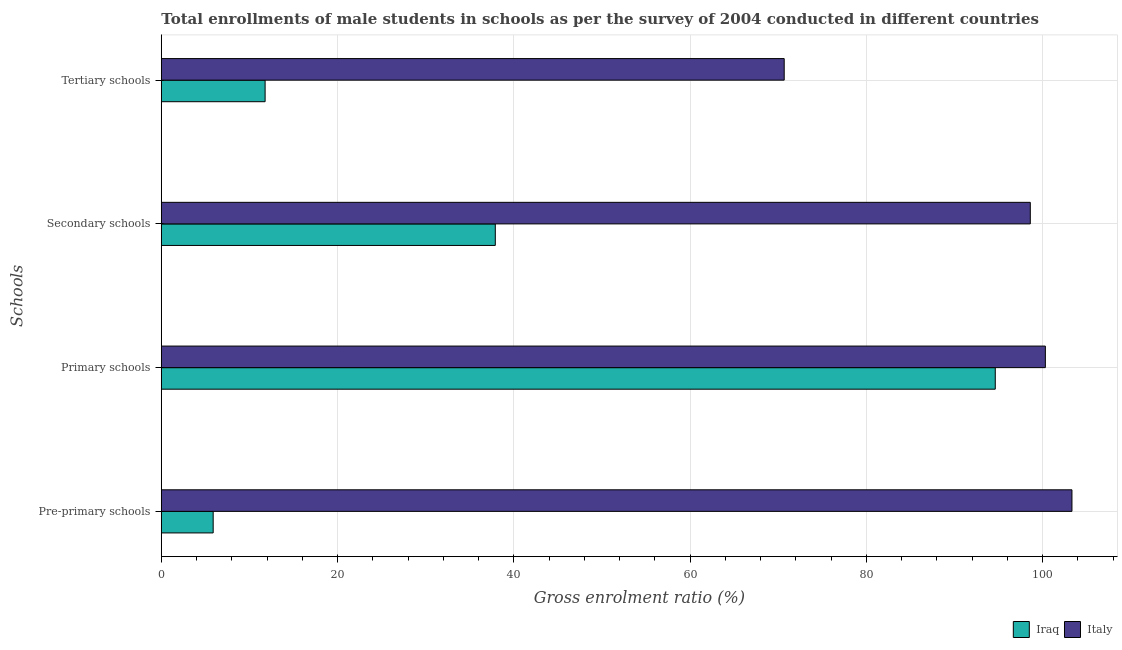How many groups of bars are there?
Your response must be concise. 4. Are the number of bars per tick equal to the number of legend labels?
Make the answer very short. Yes. What is the label of the 1st group of bars from the top?
Keep it short and to the point. Tertiary schools. What is the gross enrolment ratio(male) in tertiary schools in Italy?
Ensure brevity in your answer.  70.68. Across all countries, what is the maximum gross enrolment ratio(male) in tertiary schools?
Offer a very short reply. 70.68. Across all countries, what is the minimum gross enrolment ratio(male) in pre-primary schools?
Provide a succinct answer. 5.88. In which country was the gross enrolment ratio(male) in tertiary schools minimum?
Make the answer very short. Iraq. What is the total gross enrolment ratio(male) in secondary schools in the graph?
Make the answer very short. 136.51. What is the difference between the gross enrolment ratio(male) in primary schools in Italy and that in Iraq?
Your answer should be very brief. 5.68. What is the difference between the gross enrolment ratio(male) in primary schools in Iraq and the gross enrolment ratio(male) in tertiary schools in Italy?
Keep it short and to the point. 23.95. What is the average gross enrolment ratio(male) in tertiary schools per country?
Ensure brevity in your answer.  41.23. What is the difference between the gross enrolment ratio(male) in secondary schools and gross enrolment ratio(male) in pre-primary schools in Iraq?
Provide a short and direct response. 32.02. What is the ratio of the gross enrolment ratio(male) in tertiary schools in Iraq to that in Italy?
Provide a short and direct response. 0.17. Is the difference between the gross enrolment ratio(male) in secondary schools in Iraq and Italy greater than the difference between the gross enrolment ratio(male) in primary schools in Iraq and Italy?
Offer a very short reply. No. What is the difference between the highest and the second highest gross enrolment ratio(male) in primary schools?
Your response must be concise. 5.68. What is the difference between the highest and the lowest gross enrolment ratio(male) in secondary schools?
Ensure brevity in your answer.  60.71. In how many countries, is the gross enrolment ratio(male) in primary schools greater than the average gross enrolment ratio(male) in primary schools taken over all countries?
Your answer should be very brief. 1. Is the sum of the gross enrolment ratio(male) in tertiary schools in Italy and Iraq greater than the maximum gross enrolment ratio(male) in primary schools across all countries?
Provide a succinct answer. No. Is it the case that in every country, the sum of the gross enrolment ratio(male) in pre-primary schools and gross enrolment ratio(male) in primary schools is greater than the sum of gross enrolment ratio(male) in tertiary schools and gross enrolment ratio(male) in secondary schools?
Make the answer very short. No. What does the 2nd bar from the top in Tertiary schools represents?
Offer a terse response. Iraq. What does the 2nd bar from the bottom in Pre-primary schools represents?
Ensure brevity in your answer.  Italy. Are all the bars in the graph horizontal?
Your answer should be very brief. Yes. How many countries are there in the graph?
Provide a succinct answer. 2. What is the difference between two consecutive major ticks on the X-axis?
Your answer should be compact. 20. Are the values on the major ticks of X-axis written in scientific E-notation?
Your answer should be very brief. No. How many legend labels are there?
Offer a terse response. 2. How are the legend labels stacked?
Your response must be concise. Horizontal. What is the title of the graph?
Your response must be concise. Total enrollments of male students in schools as per the survey of 2004 conducted in different countries. Does "East Asia (all income levels)" appear as one of the legend labels in the graph?
Your answer should be compact. No. What is the label or title of the Y-axis?
Give a very brief answer. Schools. What is the Gross enrolment ratio (%) of Iraq in Pre-primary schools?
Ensure brevity in your answer.  5.88. What is the Gross enrolment ratio (%) of Italy in Pre-primary schools?
Offer a very short reply. 103.34. What is the Gross enrolment ratio (%) in Iraq in Primary schools?
Make the answer very short. 94.64. What is the Gross enrolment ratio (%) in Italy in Primary schools?
Provide a succinct answer. 100.32. What is the Gross enrolment ratio (%) of Iraq in Secondary schools?
Your response must be concise. 37.9. What is the Gross enrolment ratio (%) of Italy in Secondary schools?
Give a very brief answer. 98.61. What is the Gross enrolment ratio (%) in Iraq in Tertiary schools?
Offer a terse response. 11.78. What is the Gross enrolment ratio (%) of Italy in Tertiary schools?
Your answer should be very brief. 70.68. Across all Schools, what is the maximum Gross enrolment ratio (%) of Iraq?
Give a very brief answer. 94.64. Across all Schools, what is the maximum Gross enrolment ratio (%) in Italy?
Provide a short and direct response. 103.34. Across all Schools, what is the minimum Gross enrolment ratio (%) in Iraq?
Offer a terse response. 5.88. Across all Schools, what is the minimum Gross enrolment ratio (%) of Italy?
Give a very brief answer. 70.68. What is the total Gross enrolment ratio (%) in Iraq in the graph?
Your answer should be compact. 150.2. What is the total Gross enrolment ratio (%) of Italy in the graph?
Give a very brief answer. 372.95. What is the difference between the Gross enrolment ratio (%) in Iraq in Pre-primary schools and that in Primary schools?
Offer a terse response. -88.75. What is the difference between the Gross enrolment ratio (%) of Italy in Pre-primary schools and that in Primary schools?
Offer a very short reply. 3.02. What is the difference between the Gross enrolment ratio (%) of Iraq in Pre-primary schools and that in Secondary schools?
Keep it short and to the point. -32.02. What is the difference between the Gross enrolment ratio (%) of Italy in Pre-primary schools and that in Secondary schools?
Your response must be concise. 4.73. What is the difference between the Gross enrolment ratio (%) of Iraq in Pre-primary schools and that in Tertiary schools?
Your answer should be compact. -5.89. What is the difference between the Gross enrolment ratio (%) in Italy in Pre-primary schools and that in Tertiary schools?
Keep it short and to the point. 32.65. What is the difference between the Gross enrolment ratio (%) in Iraq in Primary schools and that in Secondary schools?
Provide a short and direct response. 56.74. What is the difference between the Gross enrolment ratio (%) in Italy in Primary schools and that in Secondary schools?
Give a very brief answer. 1.71. What is the difference between the Gross enrolment ratio (%) of Iraq in Primary schools and that in Tertiary schools?
Provide a succinct answer. 82.86. What is the difference between the Gross enrolment ratio (%) of Italy in Primary schools and that in Tertiary schools?
Make the answer very short. 29.64. What is the difference between the Gross enrolment ratio (%) in Iraq in Secondary schools and that in Tertiary schools?
Provide a short and direct response. 26.12. What is the difference between the Gross enrolment ratio (%) of Italy in Secondary schools and that in Tertiary schools?
Give a very brief answer. 27.93. What is the difference between the Gross enrolment ratio (%) in Iraq in Pre-primary schools and the Gross enrolment ratio (%) in Italy in Primary schools?
Your response must be concise. -94.44. What is the difference between the Gross enrolment ratio (%) in Iraq in Pre-primary schools and the Gross enrolment ratio (%) in Italy in Secondary schools?
Give a very brief answer. -92.73. What is the difference between the Gross enrolment ratio (%) in Iraq in Pre-primary schools and the Gross enrolment ratio (%) in Italy in Tertiary schools?
Give a very brief answer. -64.8. What is the difference between the Gross enrolment ratio (%) in Iraq in Primary schools and the Gross enrolment ratio (%) in Italy in Secondary schools?
Provide a short and direct response. -3.98. What is the difference between the Gross enrolment ratio (%) in Iraq in Primary schools and the Gross enrolment ratio (%) in Italy in Tertiary schools?
Provide a succinct answer. 23.95. What is the difference between the Gross enrolment ratio (%) in Iraq in Secondary schools and the Gross enrolment ratio (%) in Italy in Tertiary schools?
Provide a short and direct response. -32.78. What is the average Gross enrolment ratio (%) in Iraq per Schools?
Make the answer very short. 37.55. What is the average Gross enrolment ratio (%) in Italy per Schools?
Offer a terse response. 93.24. What is the difference between the Gross enrolment ratio (%) in Iraq and Gross enrolment ratio (%) in Italy in Pre-primary schools?
Give a very brief answer. -97.45. What is the difference between the Gross enrolment ratio (%) of Iraq and Gross enrolment ratio (%) of Italy in Primary schools?
Make the answer very short. -5.68. What is the difference between the Gross enrolment ratio (%) of Iraq and Gross enrolment ratio (%) of Italy in Secondary schools?
Provide a succinct answer. -60.71. What is the difference between the Gross enrolment ratio (%) of Iraq and Gross enrolment ratio (%) of Italy in Tertiary schools?
Provide a short and direct response. -58.9. What is the ratio of the Gross enrolment ratio (%) of Iraq in Pre-primary schools to that in Primary schools?
Offer a very short reply. 0.06. What is the ratio of the Gross enrolment ratio (%) in Italy in Pre-primary schools to that in Primary schools?
Provide a short and direct response. 1.03. What is the ratio of the Gross enrolment ratio (%) of Iraq in Pre-primary schools to that in Secondary schools?
Give a very brief answer. 0.16. What is the ratio of the Gross enrolment ratio (%) of Italy in Pre-primary schools to that in Secondary schools?
Ensure brevity in your answer.  1.05. What is the ratio of the Gross enrolment ratio (%) in Iraq in Pre-primary schools to that in Tertiary schools?
Offer a very short reply. 0.5. What is the ratio of the Gross enrolment ratio (%) of Italy in Pre-primary schools to that in Tertiary schools?
Keep it short and to the point. 1.46. What is the ratio of the Gross enrolment ratio (%) of Iraq in Primary schools to that in Secondary schools?
Ensure brevity in your answer.  2.5. What is the ratio of the Gross enrolment ratio (%) of Italy in Primary schools to that in Secondary schools?
Your answer should be very brief. 1.02. What is the ratio of the Gross enrolment ratio (%) of Iraq in Primary schools to that in Tertiary schools?
Your answer should be compact. 8.03. What is the ratio of the Gross enrolment ratio (%) of Italy in Primary schools to that in Tertiary schools?
Offer a terse response. 1.42. What is the ratio of the Gross enrolment ratio (%) in Iraq in Secondary schools to that in Tertiary schools?
Offer a very short reply. 3.22. What is the ratio of the Gross enrolment ratio (%) of Italy in Secondary schools to that in Tertiary schools?
Give a very brief answer. 1.4. What is the difference between the highest and the second highest Gross enrolment ratio (%) of Iraq?
Your answer should be compact. 56.74. What is the difference between the highest and the second highest Gross enrolment ratio (%) of Italy?
Offer a terse response. 3.02. What is the difference between the highest and the lowest Gross enrolment ratio (%) of Iraq?
Ensure brevity in your answer.  88.75. What is the difference between the highest and the lowest Gross enrolment ratio (%) in Italy?
Offer a very short reply. 32.65. 